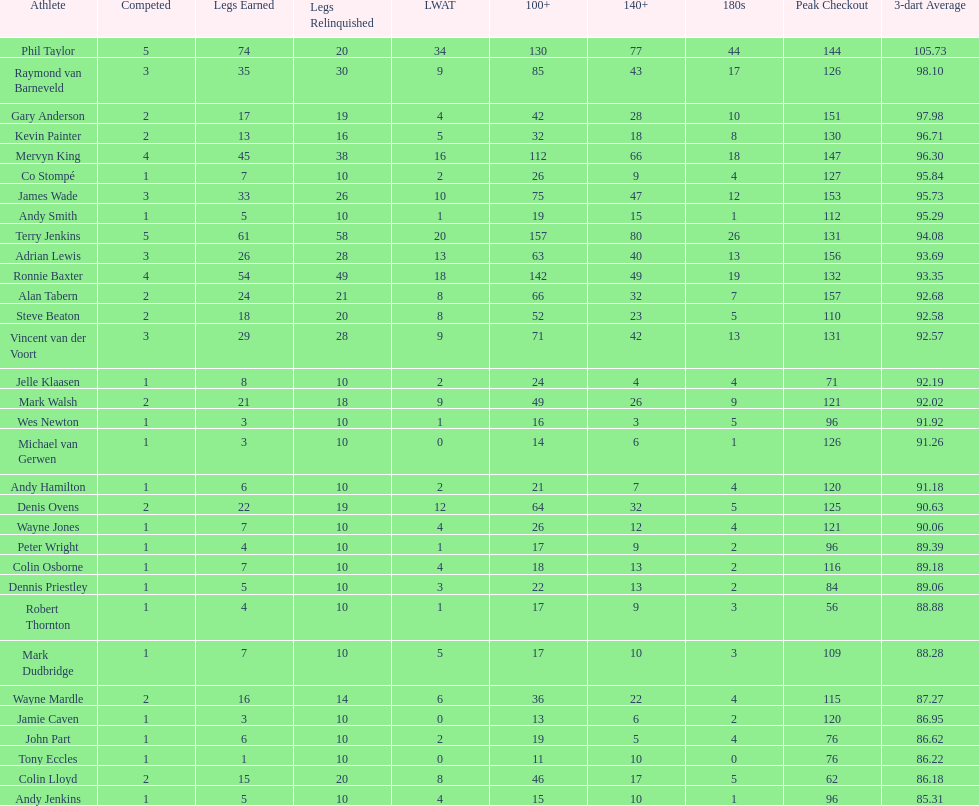Give me the full table as a dictionary. {'header': ['Athlete', 'Competed', 'Legs Earned', 'Legs Relinquished', 'LWAT', '100+', '140+', '180s', 'Peak Checkout', '3-dart Average'], 'rows': [['Phil Taylor', '5', '74', '20', '34', '130', '77', '44', '144', '105.73'], ['Raymond van Barneveld', '3', '35', '30', '9', '85', '43', '17', '126', '98.10'], ['Gary Anderson', '2', '17', '19', '4', '42', '28', '10', '151', '97.98'], ['Kevin Painter', '2', '13', '16', '5', '32', '18', '8', '130', '96.71'], ['Mervyn King', '4', '45', '38', '16', '112', '66', '18', '147', '96.30'], ['Co Stompé', '1', '7', '10', '2', '26', '9', '4', '127', '95.84'], ['James Wade', '3', '33', '26', '10', '75', '47', '12', '153', '95.73'], ['Andy Smith', '1', '5', '10', '1', '19', '15', '1', '112', '95.29'], ['Terry Jenkins', '5', '61', '58', '20', '157', '80', '26', '131', '94.08'], ['Adrian Lewis', '3', '26', '28', '13', '63', '40', '13', '156', '93.69'], ['Ronnie Baxter', '4', '54', '49', '18', '142', '49', '19', '132', '93.35'], ['Alan Tabern', '2', '24', '21', '8', '66', '32', '7', '157', '92.68'], ['Steve Beaton', '2', '18', '20', '8', '52', '23', '5', '110', '92.58'], ['Vincent van der Voort', '3', '29', '28', '9', '71', '42', '13', '131', '92.57'], ['Jelle Klaasen', '1', '8', '10', '2', '24', '4', '4', '71', '92.19'], ['Mark Walsh', '2', '21', '18', '9', '49', '26', '9', '121', '92.02'], ['Wes Newton', '1', '3', '10', '1', '16', '3', '5', '96', '91.92'], ['Michael van Gerwen', '1', '3', '10', '0', '14', '6', '1', '126', '91.26'], ['Andy Hamilton', '1', '6', '10', '2', '21', '7', '4', '120', '91.18'], ['Denis Ovens', '2', '22', '19', '12', '64', '32', '5', '125', '90.63'], ['Wayne Jones', '1', '7', '10', '4', '26', '12', '4', '121', '90.06'], ['Peter Wright', '1', '4', '10', '1', '17', '9', '2', '96', '89.39'], ['Colin Osborne', '1', '7', '10', '4', '18', '13', '2', '116', '89.18'], ['Dennis Priestley', '1', '5', '10', '3', '22', '13', '2', '84', '89.06'], ['Robert Thornton', '1', '4', '10', '1', '17', '9', '3', '56', '88.88'], ['Mark Dudbridge', '1', '7', '10', '5', '17', '10', '3', '109', '88.28'], ['Wayne Mardle', '2', '16', '14', '6', '36', '22', '4', '115', '87.27'], ['Jamie Caven', '1', '3', '10', '0', '13', '6', '2', '120', '86.95'], ['John Part', '1', '6', '10', '2', '19', '5', '4', '76', '86.62'], ['Tony Eccles', '1', '1', '10', '0', '11', '10', '0', '76', '86.22'], ['Colin Lloyd', '2', '15', '20', '8', '46', '17', '5', '62', '86.18'], ['Andy Jenkins', '1', '5', '10', '4', '15', '10', '1', '96', '85.31']]} How many players in the 2009 world matchplay won at least 30 legs? 6. 